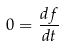Convert formula to latex. <formula><loc_0><loc_0><loc_500><loc_500>0 = { \frac { d f } { d t } }</formula> 